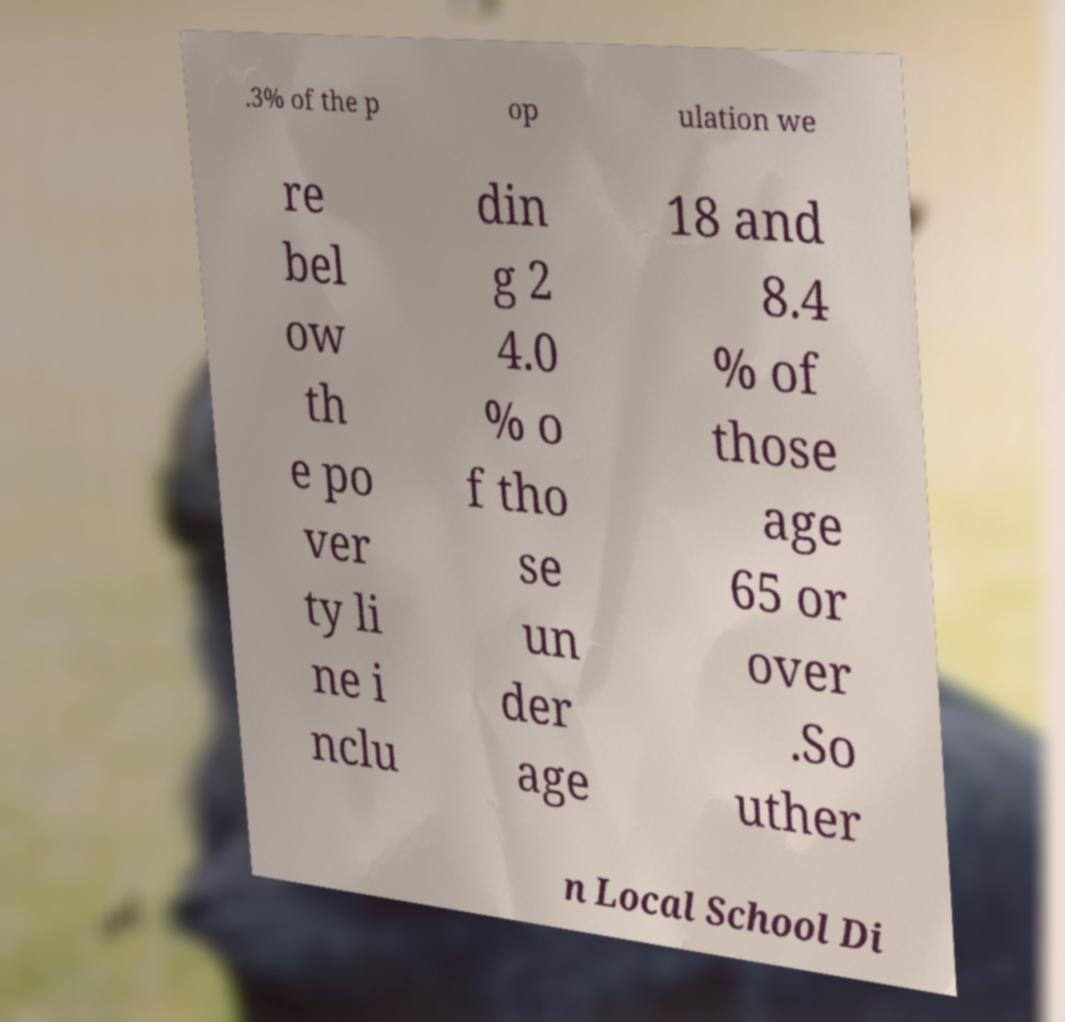For documentation purposes, I need the text within this image transcribed. Could you provide that? .3% of the p op ulation we re bel ow th e po ver ty li ne i nclu din g 2 4.0 % o f tho se un der age 18 and 8.4 % of those age 65 or over .So uther n Local School Di 